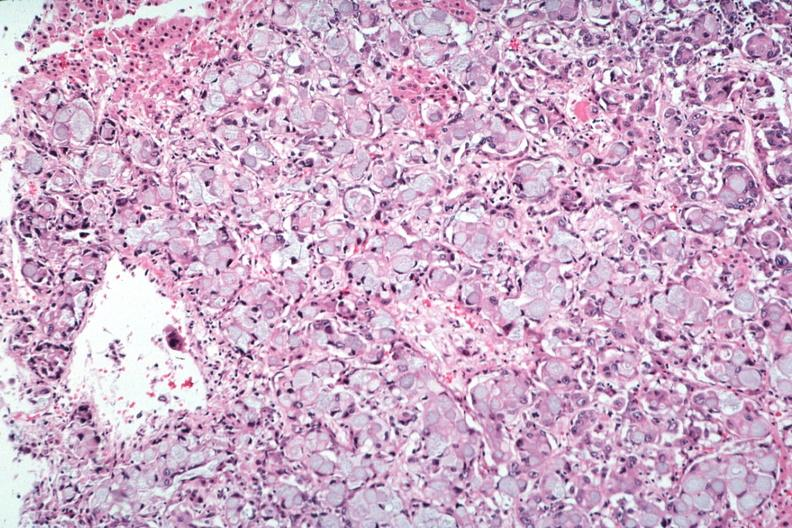s metastatic carcinoma present?
Answer the question using a single word or phrase. Yes 